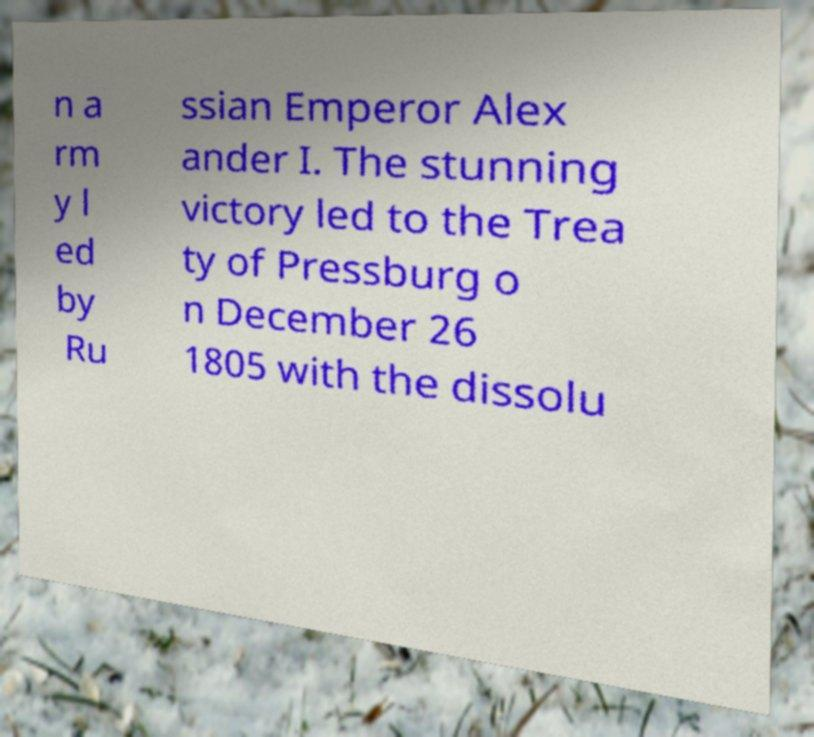Can you accurately transcribe the text from the provided image for me? n a rm y l ed by Ru ssian Emperor Alex ander I. The stunning victory led to the Trea ty of Pressburg o n December 26 1805 with the dissolu 